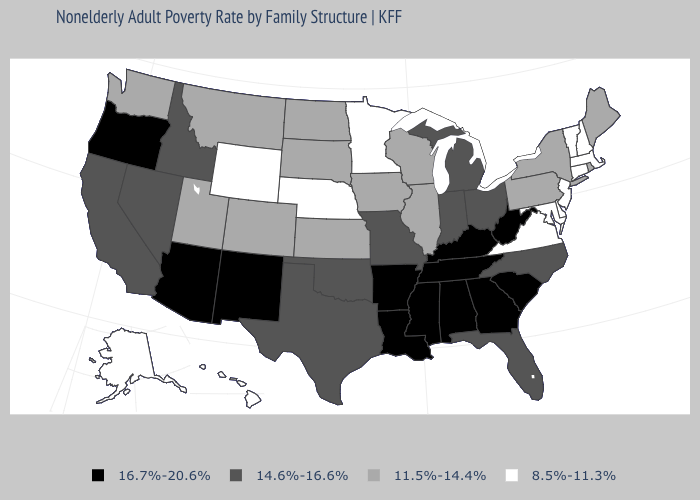Name the states that have a value in the range 8.5%-11.3%?
Give a very brief answer. Alaska, Connecticut, Delaware, Hawaii, Maryland, Massachusetts, Minnesota, Nebraska, New Hampshire, New Jersey, Vermont, Virginia, Wyoming. Does New Mexico have a higher value than Massachusetts?
Write a very short answer. Yes. What is the lowest value in the USA?
Short answer required. 8.5%-11.3%. Among the states that border Maryland , which have the highest value?
Give a very brief answer. West Virginia. Among the states that border New Jersey , does Pennsylvania have the lowest value?
Concise answer only. No. What is the value of Georgia?
Short answer required. 16.7%-20.6%. What is the value of Arizona?
Answer briefly. 16.7%-20.6%. What is the highest value in states that border West Virginia?
Keep it brief. 16.7%-20.6%. Name the states that have a value in the range 11.5%-14.4%?
Quick response, please. Colorado, Illinois, Iowa, Kansas, Maine, Montana, New York, North Dakota, Pennsylvania, Rhode Island, South Dakota, Utah, Washington, Wisconsin. What is the value of Nevada?
Answer briefly. 14.6%-16.6%. Does New Hampshire have a higher value than Rhode Island?
Answer briefly. No. Does Michigan have a higher value than Rhode Island?
Short answer required. Yes. Does Washington have the lowest value in the USA?
Give a very brief answer. No. Does the map have missing data?
Write a very short answer. No. Does New Hampshire have the lowest value in the USA?
Write a very short answer. Yes. 